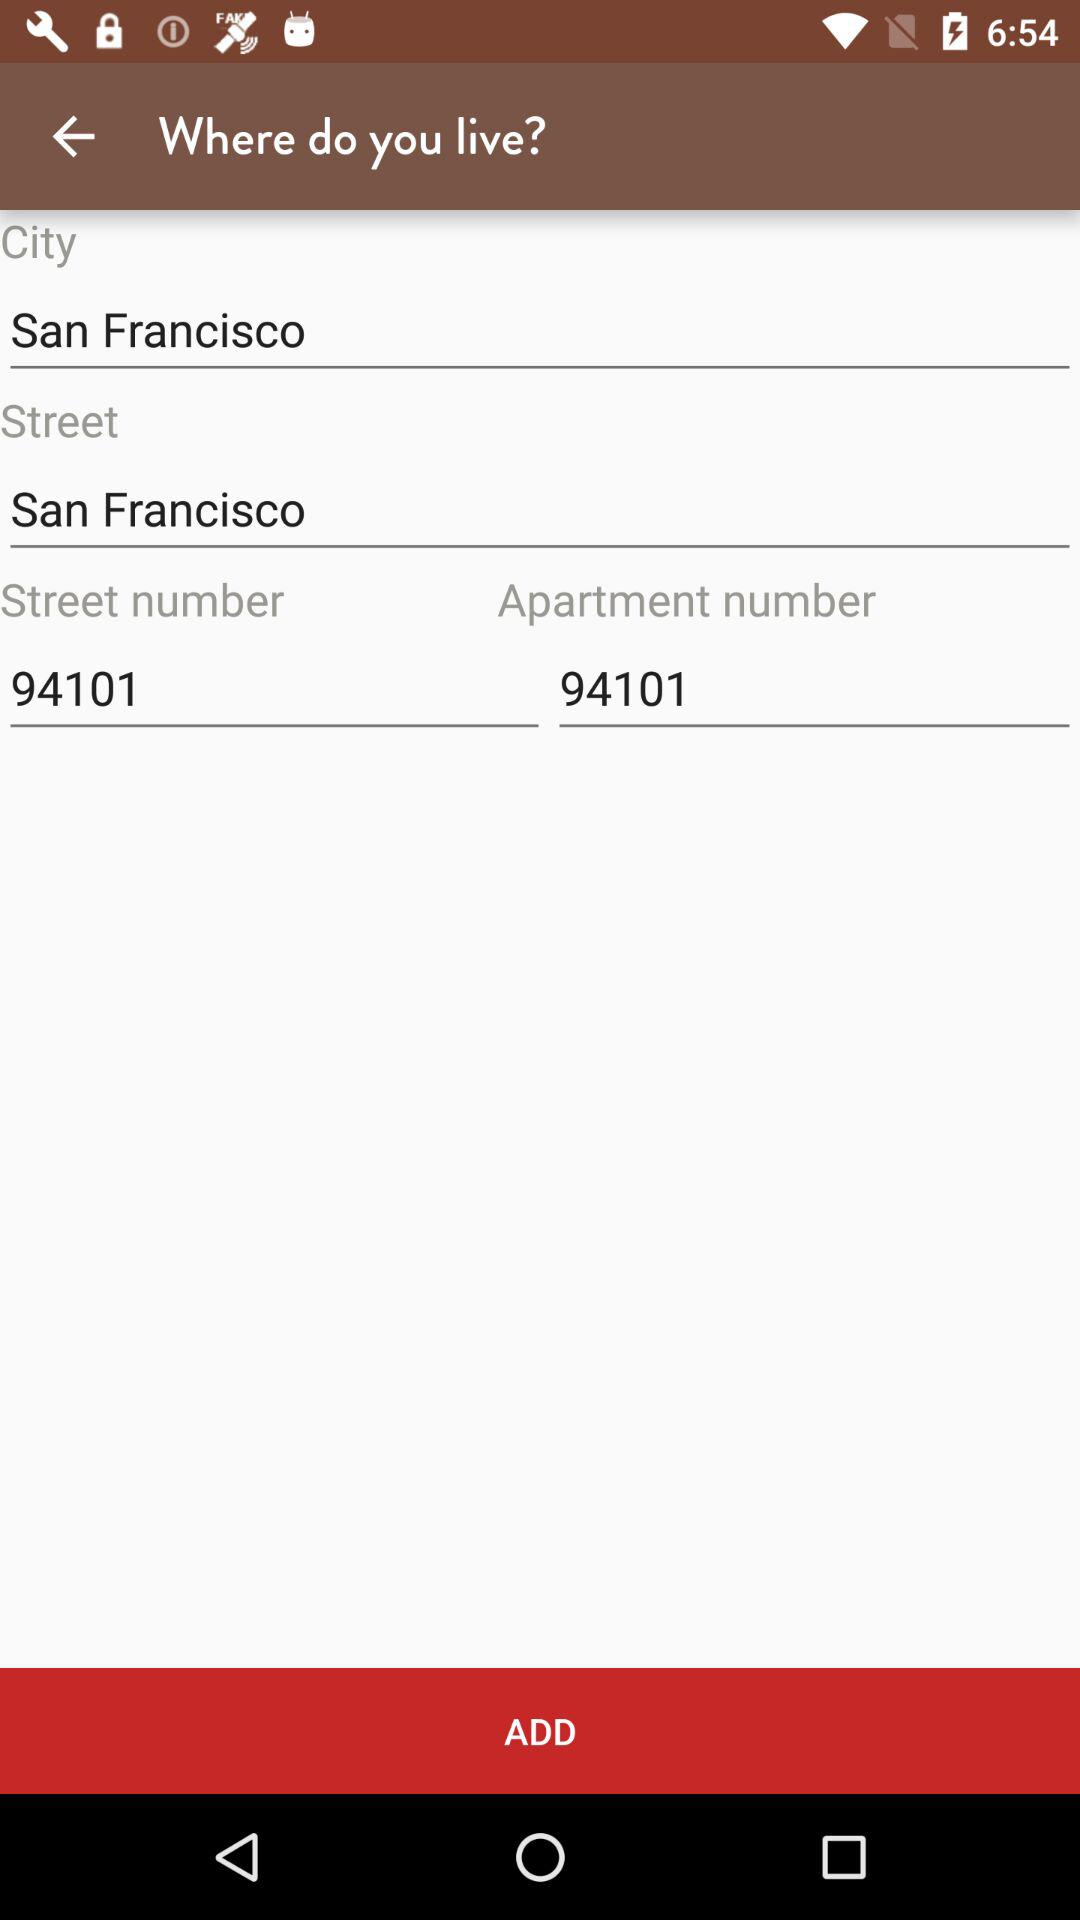How many text inputs are there for the street information?
Answer the question using a single word or phrase. 2 